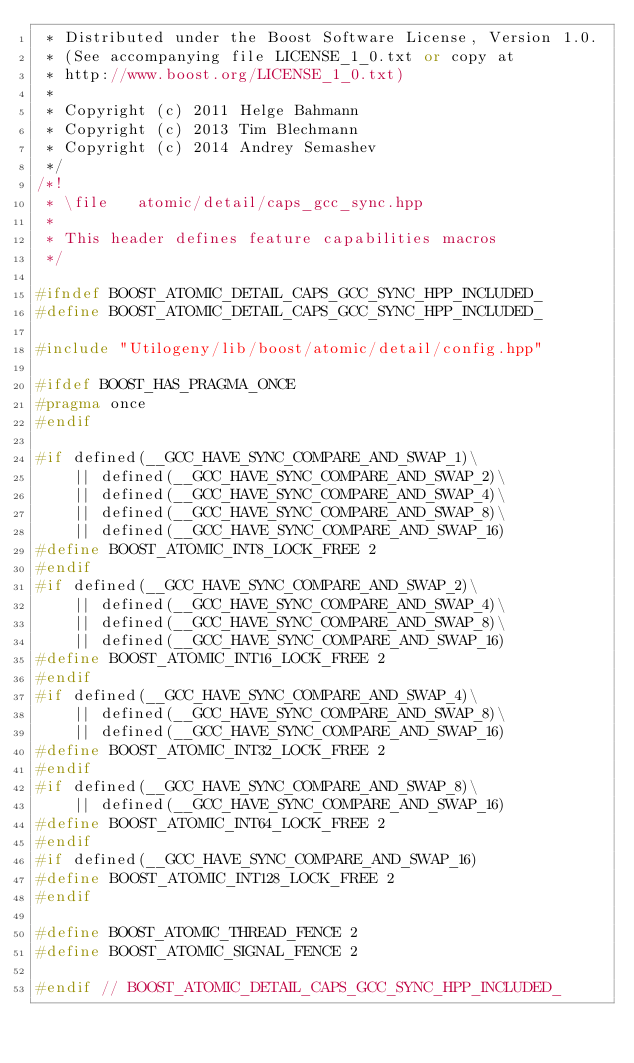<code> <loc_0><loc_0><loc_500><loc_500><_C++_> * Distributed under the Boost Software License, Version 1.0.
 * (See accompanying file LICENSE_1_0.txt or copy at
 * http://www.boost.org/LICENSE_1_0.txt)
 *
 * Copyright (c) 2011 Helge Bahmann
 * Copyright (c) 2013 Tim Blechmann
 * Copyright (c) 2014 Andrey Semashev
 */
/*!
 * \file   atomic/detail/caps_gcc_sync.hpp
 *
 * This header defines feature capabilities macros
 */

#ifndef BOOST_ATOMIC_DETAIL_CAPS_GCC_SYNC_HPP_INCLUDED_
#define BOOST_ATOMIC_DETAIL_CAPS_GCC_SYNC_HPP_INCLUDED_

#include "Utilogeny/lib/boost/atomic/detail/config.hpp"

#ifdef BOOST_HAS_PRAGMA_ONCE
#pragma once
#endif

#if defined(__GCC_HAVE_SYNC_COMPARE_AND_SWAP_1)\
    || defined(__GCC_HAVE_SYNC_COMPARE_AND_SWAP_2)\
    || defined(__GCC_HAVE_SYNC_COMPARE_AND_SWAP_4)\
    || defined(__GCC_HAVE_SYNC_COMPARE_AND_SWAP_8)\
    || defined(__GCC_HAVE_SYNC_COMPARE_AND_SWAP_16)
#define BOOST_ATOMIC_INT8_LOCK_FREE 2
#endif
#if defined(__GCC_HAVE_SYNC_COMPARE_AND_SWAP_2)\
    || defined(__GCC_HAVE_SYNC_COMPARE_AND_SWAP_4)\
    || defined(__GCC_HAVE_SYNC_COMPARE_AND_SWAP_8)\
    || defined(__GCC_HAVE_SYNC_COMPARE_AND_SWAP_16)
#define BOOST_ATOMIC_INT16_LOCK_FREE 2
#endif
#if defined(__GCC_HAVE_SYNC_COMPARE_AND_SWAP_4)\
    || defined(__GCC_HAVE_SYNC_COMPARE_AND_SWAP_8)\
    || defined(__GCC_HAVE_SYNC_COMPARE_AND_SWAP_16)
#define BOOST_ATOMIC_INT32_LOCK_FREE 2
#endif
#if defined(__GCC_HAVE_SYNC_COMPARE_AND_SWAP_8)\
    || defined(__GCC_HAVE_SYNC_COMPARE_AND_SWAP_16)
#define BOOST_ATOMIC_INT64_LOCK_FREE 2
#endif
#if defined(__GCC_HAVE_SYNC_COMPARE_AND_SWAP_16)
#define BOOST_ATOMIC_INT128_LOCK_FREE 2
#endif

#define BOOST_ATOMIC_THREAD_FENCE 2
#define BOOST_ATOMIC_SIGNAL_FENCE 2

#endif // BOOST_ATOMIC_DETAIL_CAPS_GCC_SYNC_HPP_INCLUDED_
</code> 